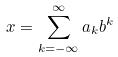<formula> <loc_0><loc_0><loc_500><loc_500>x = \sum _ { k = - \infty } ^ { \infty } a _ { k } b ^ { k }</formula> 